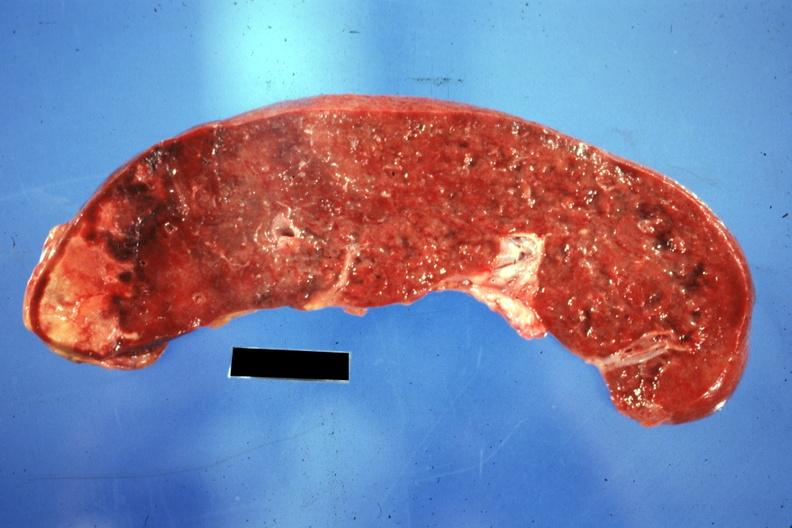where is this part in?
Answer the question using a single word or phrase. Spleen 